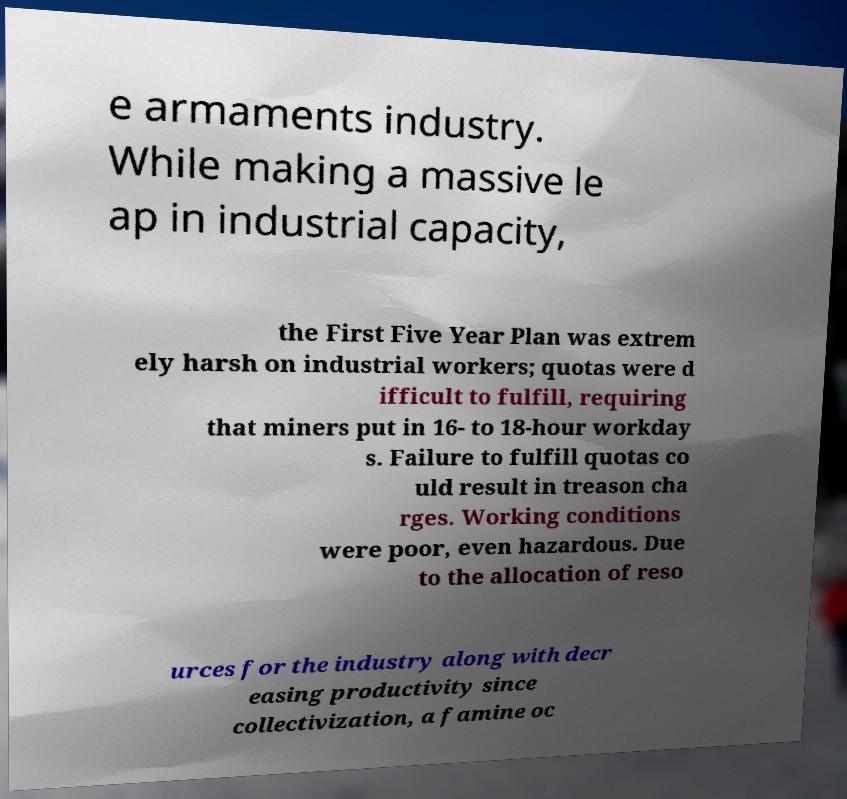Can you accurately transcribe the text from the provided image for me? e armaments industry. While making a massive le ap in industrial capacity, the First Five Year Plan was extrem ely harsh on industrial workers; quotas were d ifficult to fulfill, requiring that miners put in 16- to 18-hour workday s. Failure to fulfill quotas co uld result in treason cha rges. Working conditions were poor, even hazardous. Due to the allocation of reso urces for the industry along with decr easing productivity since collectivization, a famine oc 